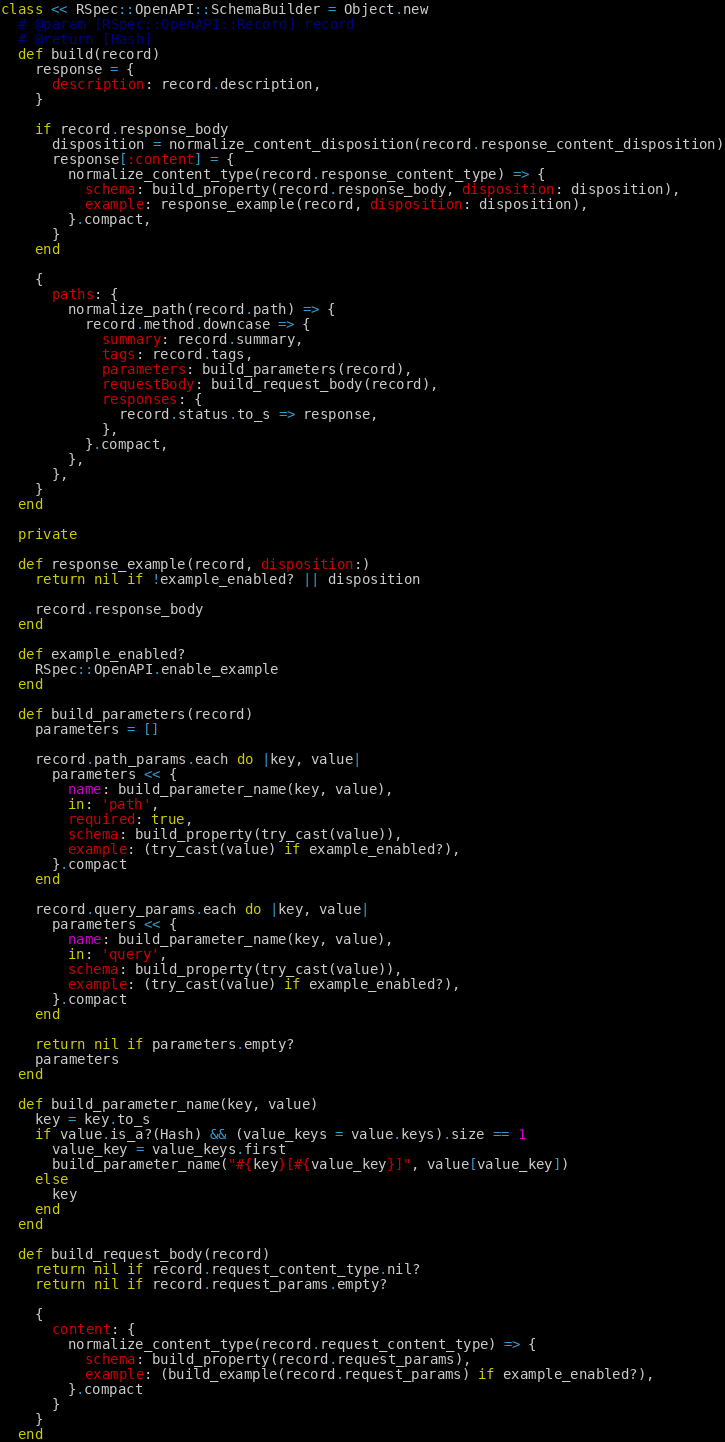<code> <loc_0><loc_0><loc_500><loc_500><_Ruby_>class << RSpec::OpenAPI::SchemaBuilder = Object.new
  # @param [RSpec::OpenAPI::Record] record
  # @return [Hash]
  def build(record)
    response = {
      description: record.description,
    }

    if record.response_body
      disposition = normalize_content_disposition(record.response_content_disposition)
      response[:content] = {
        normalize_content_type(record.response_content_type) => {
          schema: build_property(record.response_body, disposition: disposition),
          example: response_example(record, disposition: disposition),
        }.compact,
      }
    end

    {
      paths: {
        normalize_path(record.path) => {
          record.method.downcase => {
            summary: record.summary,
            tags: record.tags,
            parameters: build_parameters(record),
            requestBody: build_request_body(record),
            responses: {
              record.status.to_s => response,
            },
          }.compact,
        },
      },
    }
  end

  private

  def response_example(record, disposition:)
    return nil if !example_enabled? || disposition

    record.response_body
  end

  def example_enabled?
    RSpec::OpenAPI.enable_example
  end

  def build_parameters(record)
    parameters = []

    record.path_params.each do |key, value|
      parameters << {
        name: build_parameter_name(key, value),
        in: 'path',
        required: true,
        schema: build_property(try_cast(value)),
        example: (try_cast(value) if example_enabled?),
      }.compact
    end

    record.query_params.each do |key, value|
      parameters << {
        name: build_parameter_name(key, value),
        in: 'query',
        schema: build_property(try_cast(value)),
        example: (try_cast(value) if example_enabled?),
      }.compact
    end

    return nil if parameters.empty?
    parameters
  end

  def build_parameter_name(key, value)
    key = key.to_s
    if value.is_a?(Hash) && (value_keys = value.keys).size == 1
      value_key = value_keys.first
      build_parameter_name("#{key}[#{value_key}]", value[value_key])
    else
      key
    end
  end

  def build_request_body(record)
    return nil if record.request_content_type.nil?
    return nil if record.request_params.empty?

    {
      content: {
        normalize_content_type(record.request_content_type) => {
          schema: build_property(record.request_params),
          example: (build_example(record.request_params) if example_enabled?),
        }.compact
      }
    }
  end
</code> 